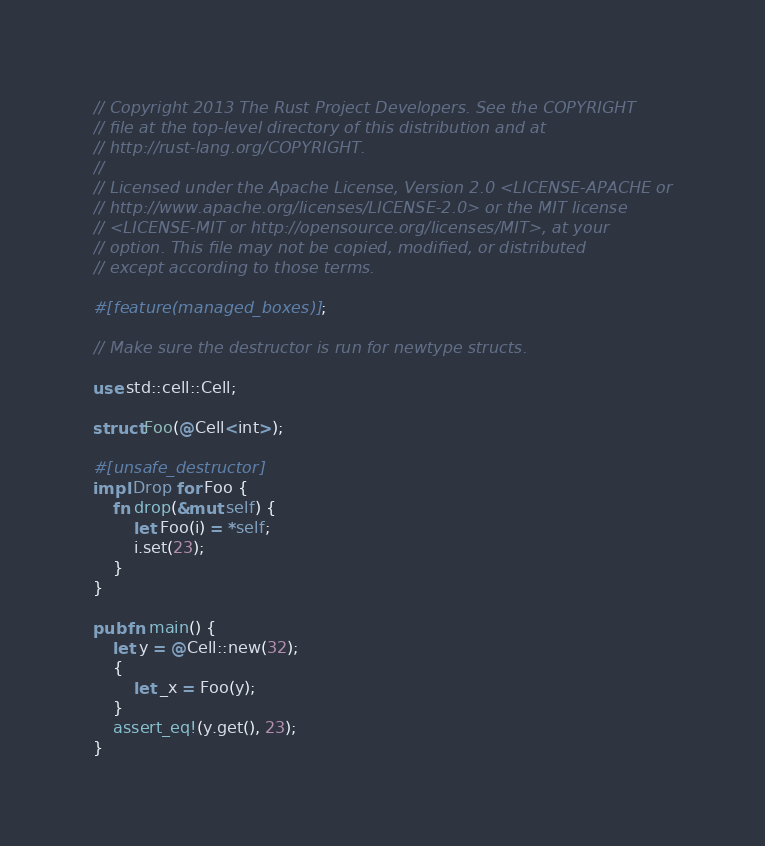Convert code to text. <code><loc_0><loc_0><loc_500><loc_500><_Rust_>// Copyright 2013 The Rust Project Developers. See the COPYRIGHT
// file at the top-level directory of this distribution and at
// http://rust-lang.org/COPYRIGHT.
//
// Licensed under the Apache License, Version 2.0 <LICENSE-APACHE or
// http://www.apache.org/licenses/LICENSE-2.0> or the MIT license
// <LICENSE-MIT or http://opensource.org/licenses/MIT>, at your
// option. This file may not be copied, modified, or distributed
// except according to those terms.

#[feature(managed_boxes)];

// Make sure the destructor is run for newtype structs.

use std::cell::Cell;

struct Foo(@Cell<int>);

#[unsafe_destructor]
impl Drop for Foo {
    fn drop(&mut self) {
        let Foo(i) = *self;
        i.set(23);
    }
}

pub fn main() {
    let y = @Cell::new(32);
    {
        let _x = Foo(y);
    }
    assert_eq!(y.get(), 23);
}
</code> 